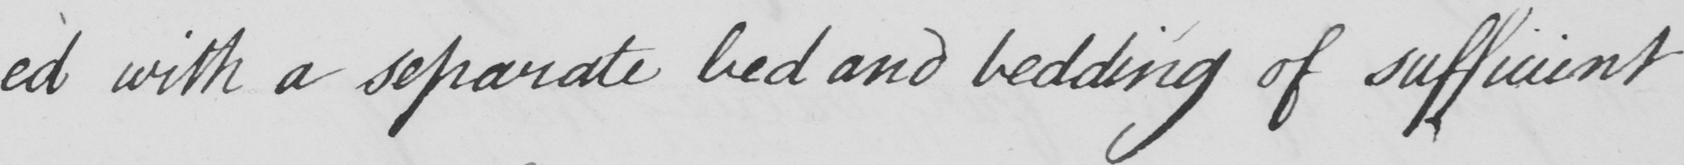What does this handwritten line say? -ed with a separate bed and bedding of sufficient 